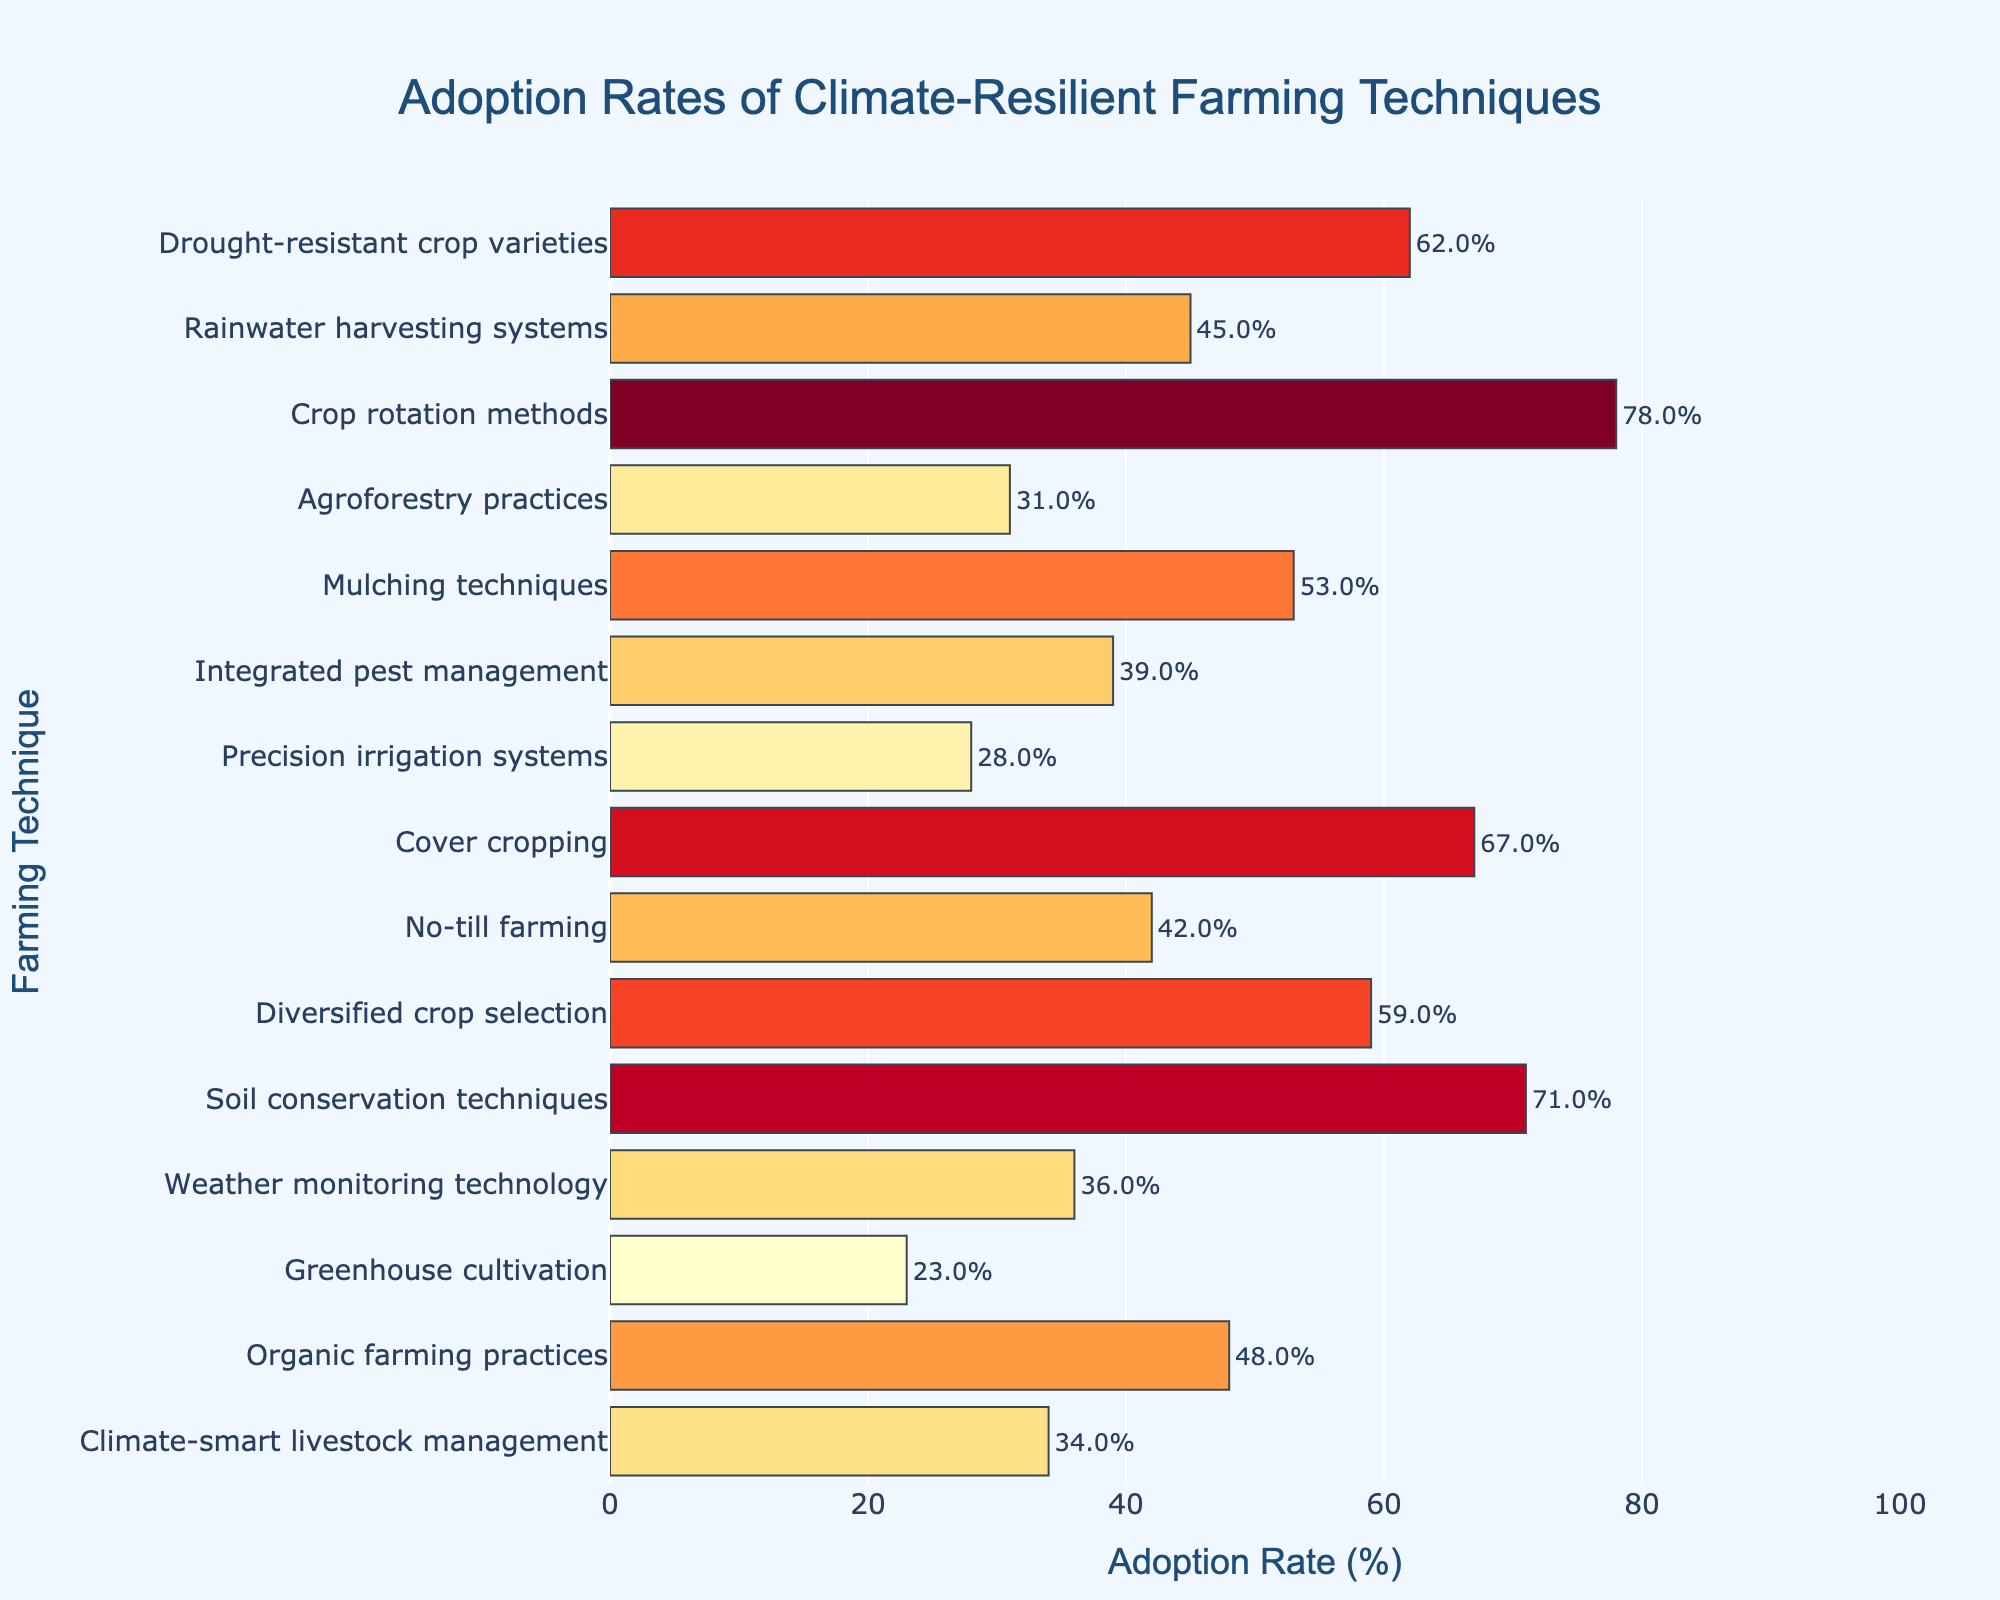Which farming technique has the lowest adoption rate? To find the technique with the lowest adoption rate, look for the shortest bar in the chart, as the height indicates the adoption rate. The shortest bar corresponds to "Greenhouse cultivation."
Answer: Greenhouse cultivation Which farming technique has the highest adoption rate? To determine the technique with the highest adoption rate, find the longest bar in the chart. The longest bar corresponds to "Crop rotation methods."
Answer: Crop rotation methods What is the average adoption rate of the top three techniques? The top three techniques with the highest adoption rates are "Crop rotation methods" (78%), "Soil conservation techniques" (71%), and "Cover cropping" (67%). To find the average: (78 + 71 + 67) / 3 = 216 / 3 = 72
Answer: 72 Which technique has a higher adoption rate: Rainwater harvesting systems or No-till farming? Compare the heights of the bars for "Rainwater harvesting systems" (45%) and "No-till farming" (42%). Since 45% is greater than 42%, "Rainwater harvesting systems" has a higher adoption rate.
Answer: Rainwater harvesting systems How much higher is the adoption rate of Integrated pest management compared to Weather monitoring technology? The adoption rates for "Integrated pest management" and "Weather monitoring technology" are 39% and 36%, respectively. To find the difference: 39% - 36% = 3%
Answer: 3% What is the combined adoption rate of Mulching techniques and organic farming practices? The adoption rates for "Mulching techniques" and "Organic farming practices" are 53% and 48%, respectively. To find the combined rate: 53% + 48% = 101%
Answer: 101% Compare the adoption rates of Agroforestry practices and Precision irrigation systems. Which one is adopted more, and by how much? The adoption rates are 31% for "Agroforestry practices" and 28% for "Precision irrigation systems." To determine the difference: 31% - 28% = 3%. "Agroforestry practices" is adopted more by 3%.
Answer: Agroforestry practices by 3% What is the adoption rate difference between the least adopted and most adopted techniques? The least adopted technique is "Greenhouse cultivation" (23%), and the most adopted is "Crop rotation methods" (78%). The difference is 78% - 23% = 55%.
Answer: 55% List all farming techniques with adoption rates above 50%. Techniques with adoption rates above 50% are "Drought-resistant crop varieties" (62%), "Crop rotation methods" (78%), "Mulching techniques" (53%), "Cover cropping" (67%), and "Soil conservation techniques" (71%).
Answer: Drought-resistant crop varieties, Crop rotation methods, Mulching techniques, Cover cropping, Soil conservation techniques What is the median adoption rate of all the techniques? To find the median, list all adoption rates in ascending order: 23%, 28%, 31%, 34%, 36%, 39%, 42%, 45%, 48%, 53%, 59%, 62%, 67%, 71%, 78%. The median value, being the middle value in this ordered list, is the 8th value: 45%.
Answer: 45% 